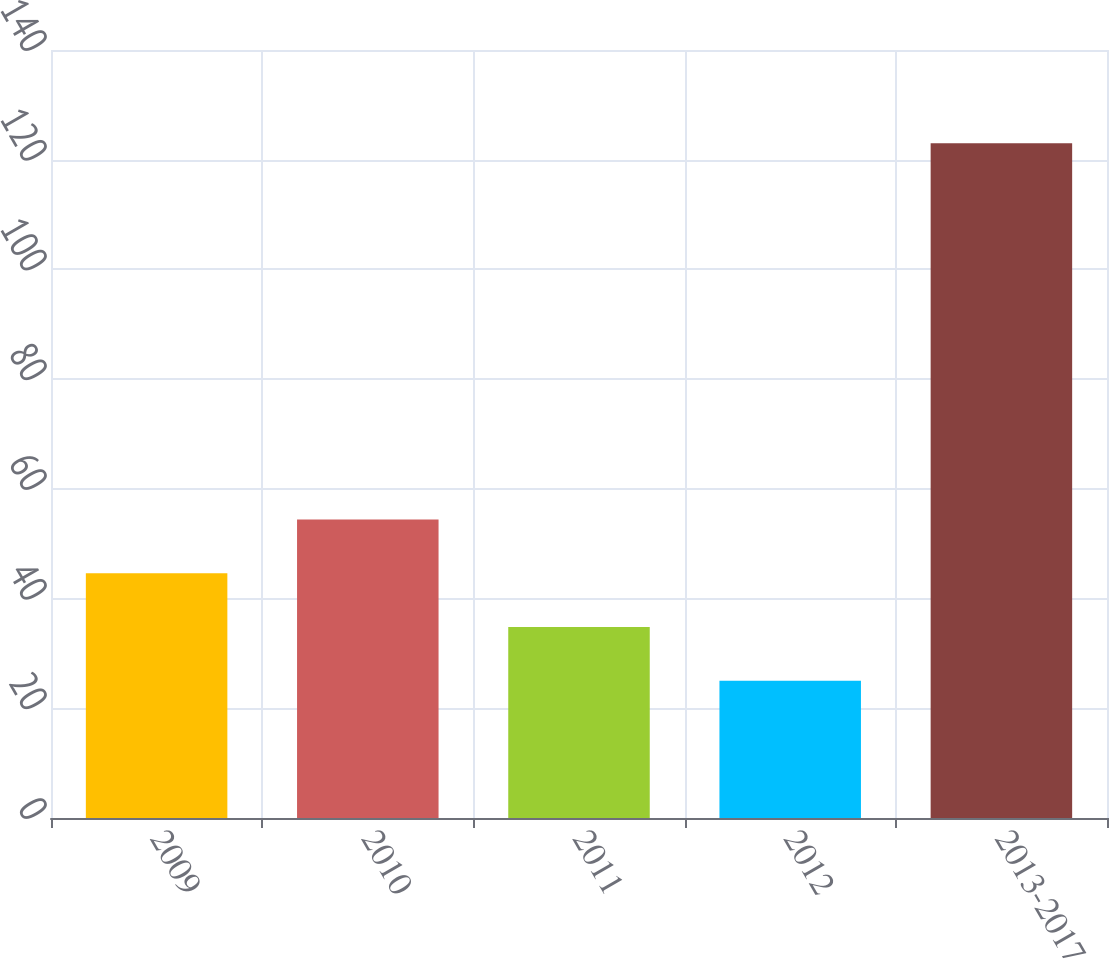Convert chart. <chart><loc_0><loc_0><loc_500><loc_500><bar_chart><fcel>2009<fcel>2010<fcel>2011<fcel>2012<fcel>2013-2017<nl><fcel>44.6<fcel>54.4<fcel>34.8<fcel>25<fcel>123<nl></chart> 